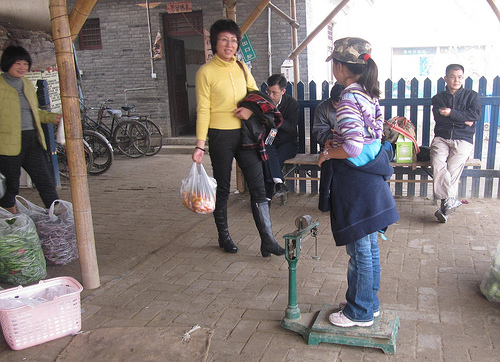<image>
Is the hat on the man? No. The hat is not positioned on the man. They may be near each other, but the hat is not supported by or resting on top of the man. Where is the bicycle in relation to the bag? Is it behind the bag? Yes. From this viewpoint, the bicycle is positioned behind the bag, with the bag partially or fully occluding the bicycle. 